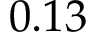<formula> <loc_0><loc_0><loc_500><loc_500>0 . 1 3</formula> 